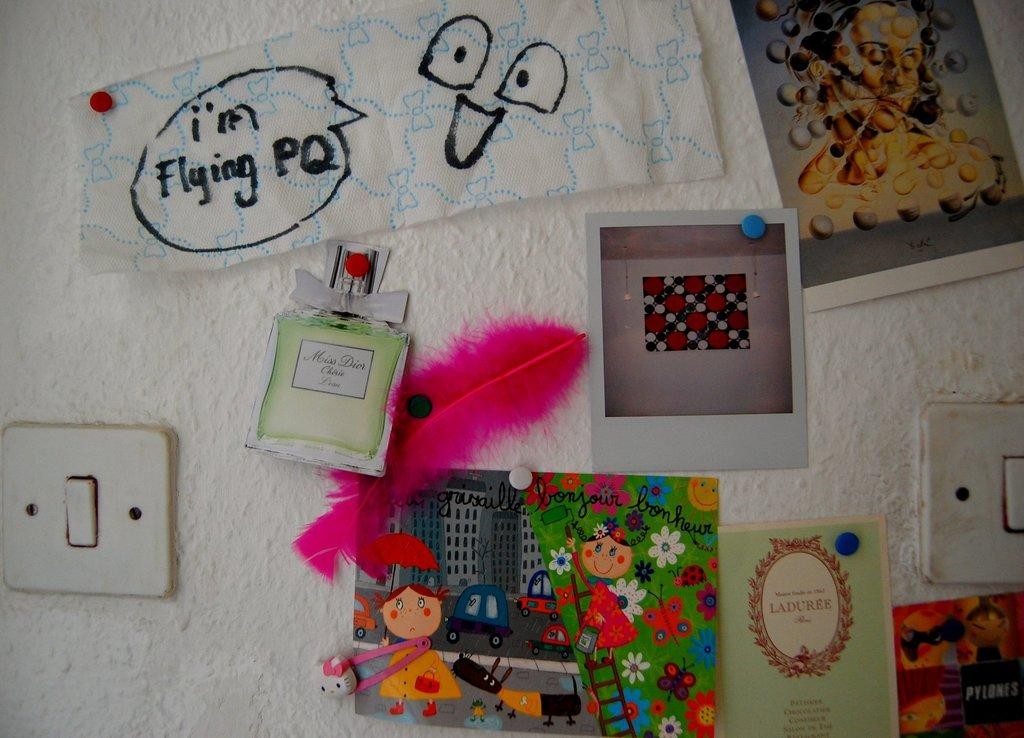<image>
Relay a brief, clear account of the picture shown. a dialog bubble saying I'm flying PQ in it 